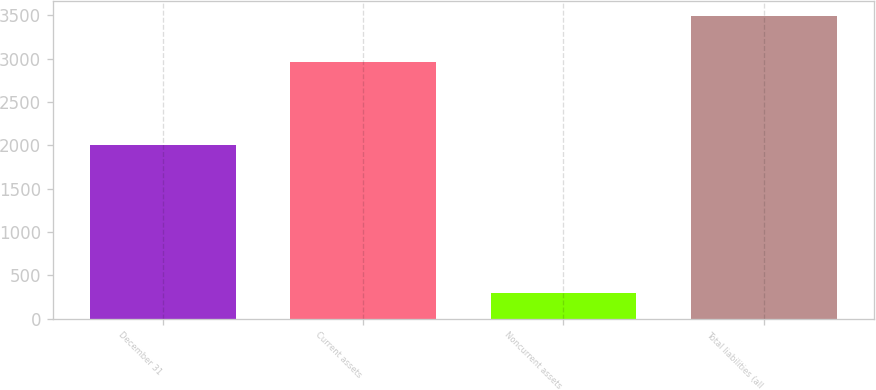Convert chart. <chart><loc_0><loc_0><loc_500><loc_500><bar_chart><fcel>December 31<fcel>Current assets<fcel>Noncurrent assets<fcel>Total liabilities (all<nl><fcel>2009<fcel>2956<fcel>295<fcel>3489<nl></chart> 